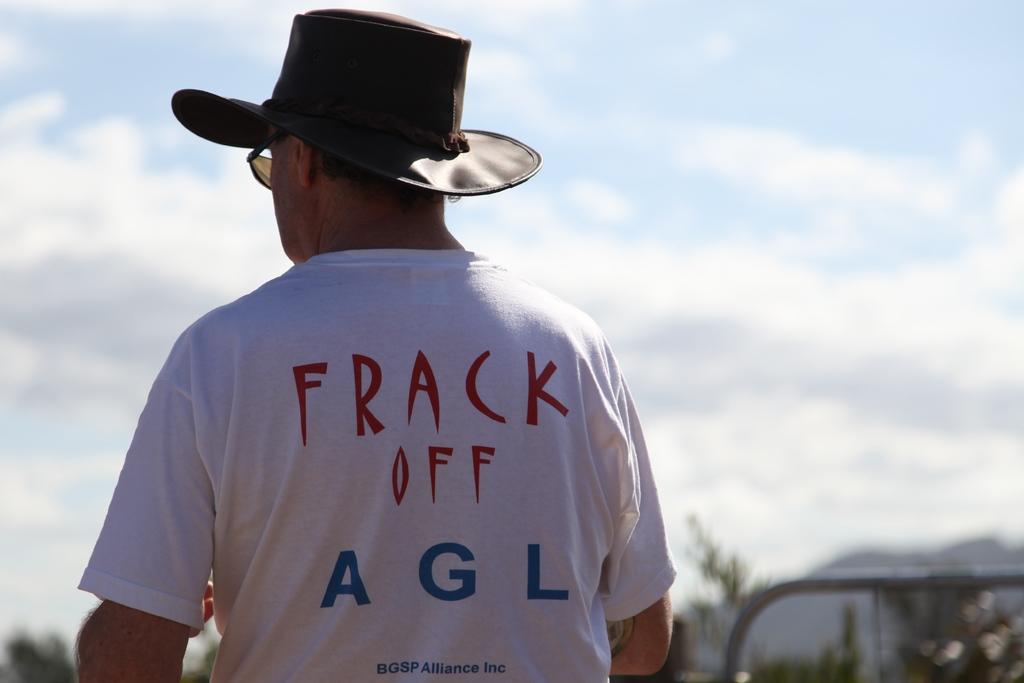What's in red on the shirt?
Make the answer very short. Frack off. 